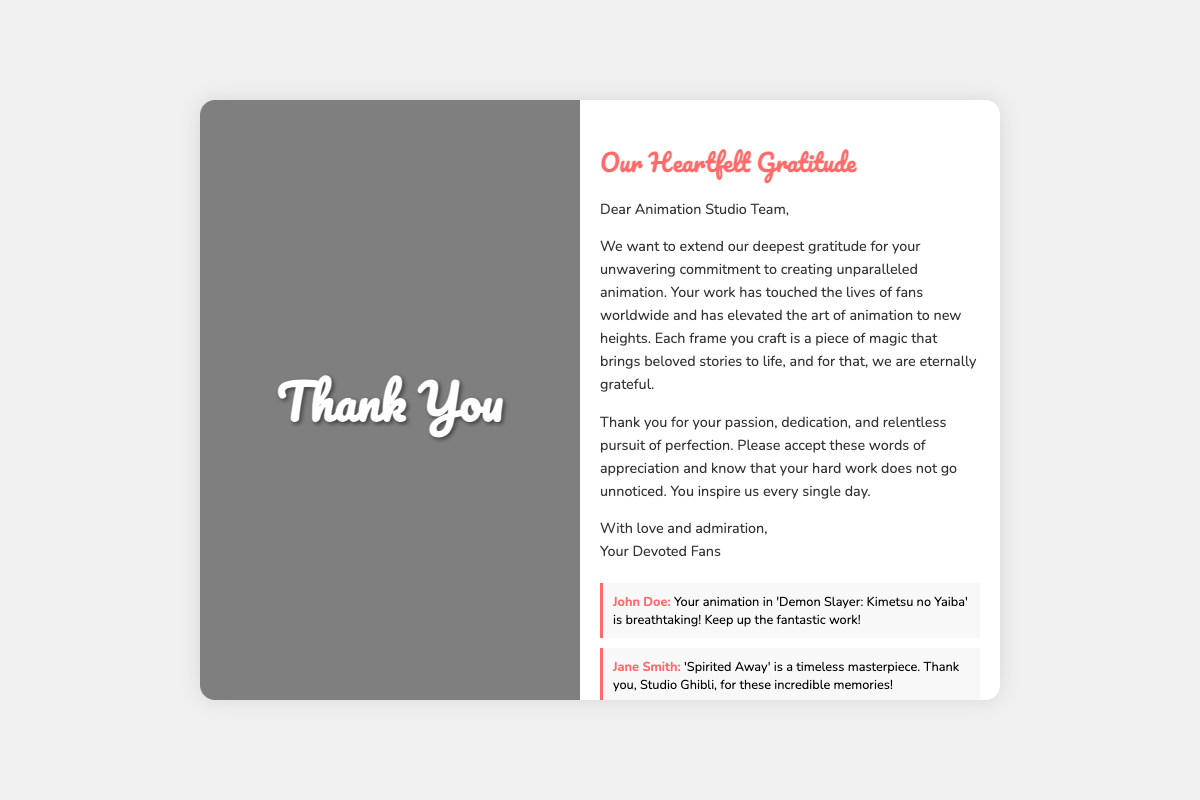What is the title of the card? The title of the card is displayed prominently on the cover.
Answer: Thank You Who is the card addressed to? The card begins with a direct address to the intended recipients.
Answer: Animation Studio Team What is one of the animated works mentioned? The autographs mention specific animated works that the fans appreciate.
Answer: Demon Slayer: Kimetsu no Yaiba How many autographs are displayed? The document showcases a total of four autographs from fans.
Answer: Four What theme is associated with Studio Ghibli? One of the themes listed specifically mentions a work by Studio Ghibli.
Answer: My Neighbor Totoro What emotion does the card convey? The overall message of the card expresses a specific sentiment toward the studio.
Answer: Gratitude What is the message regarding dedication? The card includes an acknowledgment of the studio's commitment to their craft.
Answer: Unwavering commitment Who is the author of the personalized message? The message is signed off by a collective group rather than an individual.
Answer: Your Devoted Fans 